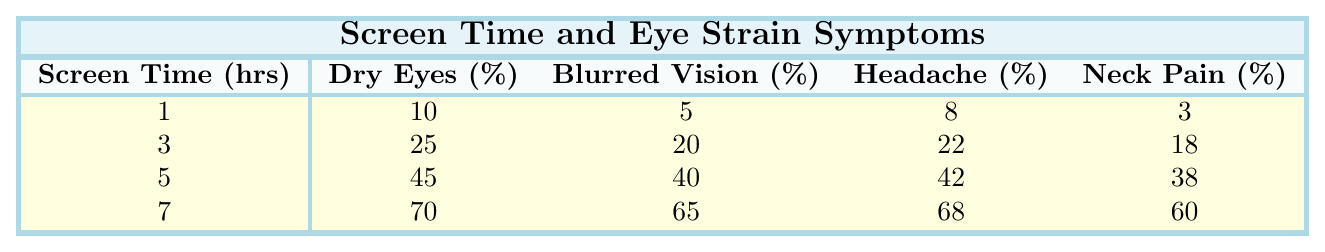What percentage of people report dry eyes after 1 hour of screen time? From the table, when screen time is 1 hour, the reported percentage of dry eyes is 10%.
Answer: 10% What is the highest reported percentage of blurred vision? The table shows that the highest percentage of blurred vision is 75%, which corresponds to 8 hours of screen time.
Answer: 75% If a person reports 45% headache symptoms, how many hours of screen time did they likely have? Looking at the table, the percentage of headaches reaches 42% at 5 hours and 58% at 6 hours. Therefore, 45% most likely correlates with between 5 and 6 hours of screen time.
Answer: Between 5 and 6 hours Is the percentage of neck pain higher at 5 hours or 6 hours of screen time? The reported percentage of neck pain at 5 hours is 38%, and at 6 hours, it is 50%. Therefore, neck pain is higher at 6 hours of screen time.
Answer: Yes, higher at 6 hours What is the average percentage of dry eyes reported across all screen time durations shown? To find the average for dry eyes: (10 + 15 + 25 + 35 + 45 + 60 + 70 + 80) / 8 = 45%.
Answer: 45% How much higher is the average blurred vision percentage than the average dry eyes percentage? The average percentage for blurred vision: (5 + 10 + 20 + 30 + 40 + 55 + 65 + 75) / 8 = 37.5%. The average for dry eyes is 45%. The difference is 45% - 37.5% = 7.5%.
Answer: 7.5% What trends can be observed in headache percentages as screen time increases? The headache percentages increase consistently with screen time: 8% at 1 hour, reaching 78% at 8 hours. This indicates a positive correlation between increased screen time and reported headache symptoms.
Answer: Consistent increase At what point does the reported percentage of light sensitivity become greater than 30%? Reviewing the table shows that light sensitivity is 35% starting at 5 hours of screen time. Therefore, it becomes greater than 30% at 5 hours.
Answer: At 5 hours If someone experiences all five symptoms after screen time, which symptom is least likely to be reported? Based on the table, at 8 hours of screen time, the least reported symptom is neck pain at 70%, compared to other symptoms reported.
Answer: Neck pain If 4 hours of screen time results in 35% dry eyes, is this higher or lower than the average? The average percentage for dry eyes (calculated earlier) is 45%. Therefore, 35% is lower than the average.
Answer: Lower 